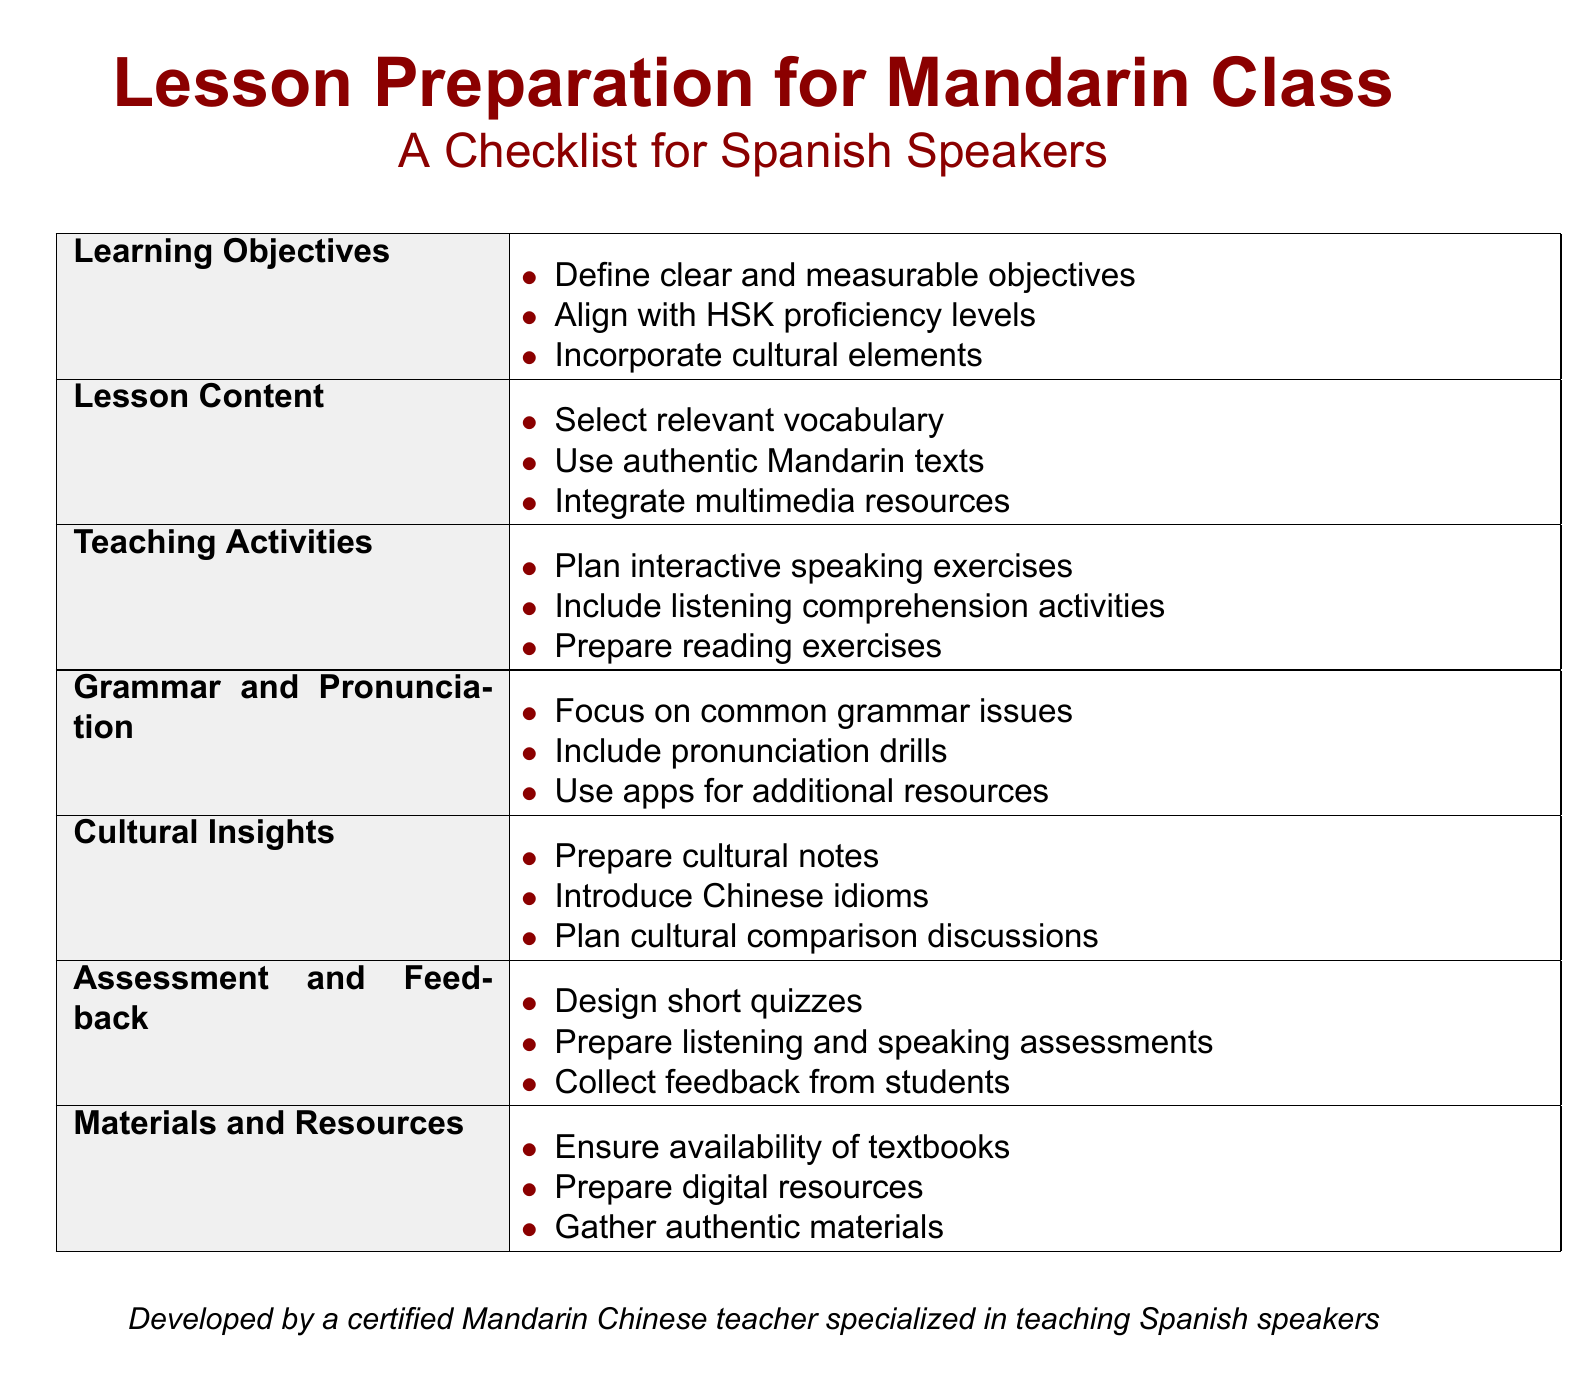What are the learning objectives? The learning objectives are clearly defined in the checklist and include defining measurable objectives, aligning with HSK proficiency levels, and incorporating cultural elements.
Answer: Clear and measurable objectives, align with HSK proficiency levels, incorporate cultural elements Which section includes multimedia resources? The section on lesson content specifically mentions the integration of multimedia resources as part of the preparation process.
Answer: Lesson Content How many teaching activities are listed? The checklist lists three specific teaching activities that should be planned for the lesson.
Answer: Three What types of assessments are suggested? The document suggests designing short quizzes and preparing listening and speaking assessments as part of the feedback and assessment process.
Answer: Short quizzes and listening and speaking assessments What cultural elements should be introduced? The cultural insights section highlights the introduction of cultural notes and Chinese idioms as essential parts of the lesson.
Answer: Cultural notes, Chinese idioms What is the main purpose of this document? The document serves as a checklist specifically tailored to prepare Spanish speakers for Mandarin classes effectively.
Answer: Lesson Preparation for Mandarin Class 